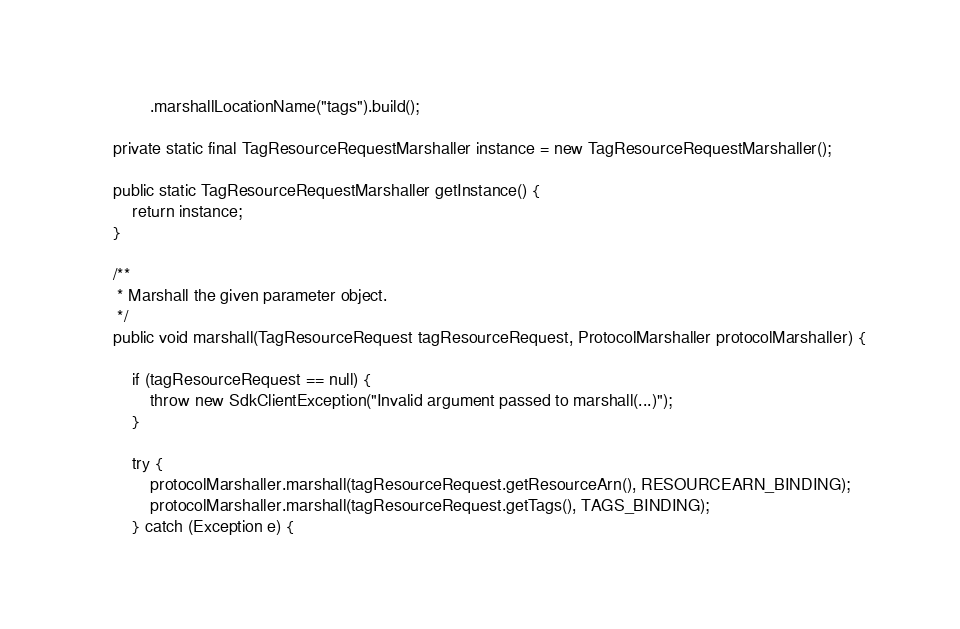<code> <loc_0><loc_0><loc_500><loc_500><_Java_>            .marshallLocationName("tags").build();

    private static final TagResourceRequestMarshaller instance = new TagResourceRequestMarshaller();

    public static TagResourceRequestMarshaller getInstance() {
        return instance;
    }

    /**
     * Marshall the given parameter object.
     */
    public void marshall(TagResourceRequest tagResourceRequest, ProtocolMarshaller protocolMarshaller) {

        if (tagResourceRequest == null) {
            throw new SdkClientException("Invalid argument passed to marshall(...)");
        }

        try {
            protocolMarshaller.marshall(tagResourceRequest.getResourceArn(), RESOURCEARN_BINDING);
            protocolMarshaller.marshall(tagResourceRequest.getTags(), TAGS_BINDING);
        } catch (Exception e) {</code> 